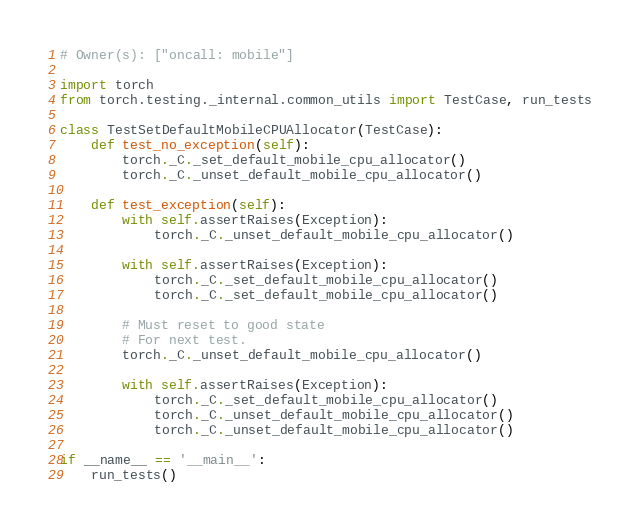Convert code to text. <code><loc_0><loc_0><loc_500><loc_500><_Python_># Owner(s): ["oncall: mobile"]

import torch
from torch.testing._internal.common_utils import TestCase, run_tests

class TestSetDefaultMobileCPUAllocator(TestCase):
    def test_no_exception(self):
        torch._C._set_default_mobile_cpu_allocator()
        torch._C._unset_default_mobile_cpu_allocator()

    def test_exception(self):
        with self.assertRaises(Exception):
            torch._C._unset_default_mobile_cpu_allocator()

        with self.assertRaises(Exception):
            torch._C._set_default_mobile_cpu_allocator()
            torch._C._set_default_mobile_cpu_allocator()

        # Must reset to good state
        # For next test.
        torch._C._unset_default_mobile_cpu_allocator()

        with self.assertRaises(Exception):
            torch._C._set_default_mobile_cpu_allocator()
            torch._C._unset_default_mobile_cpu_allocator()
            torch._C._unset_default_mobile_cpu_allocator()

if __name__ == '__main__':
    run_tests()
</code> 